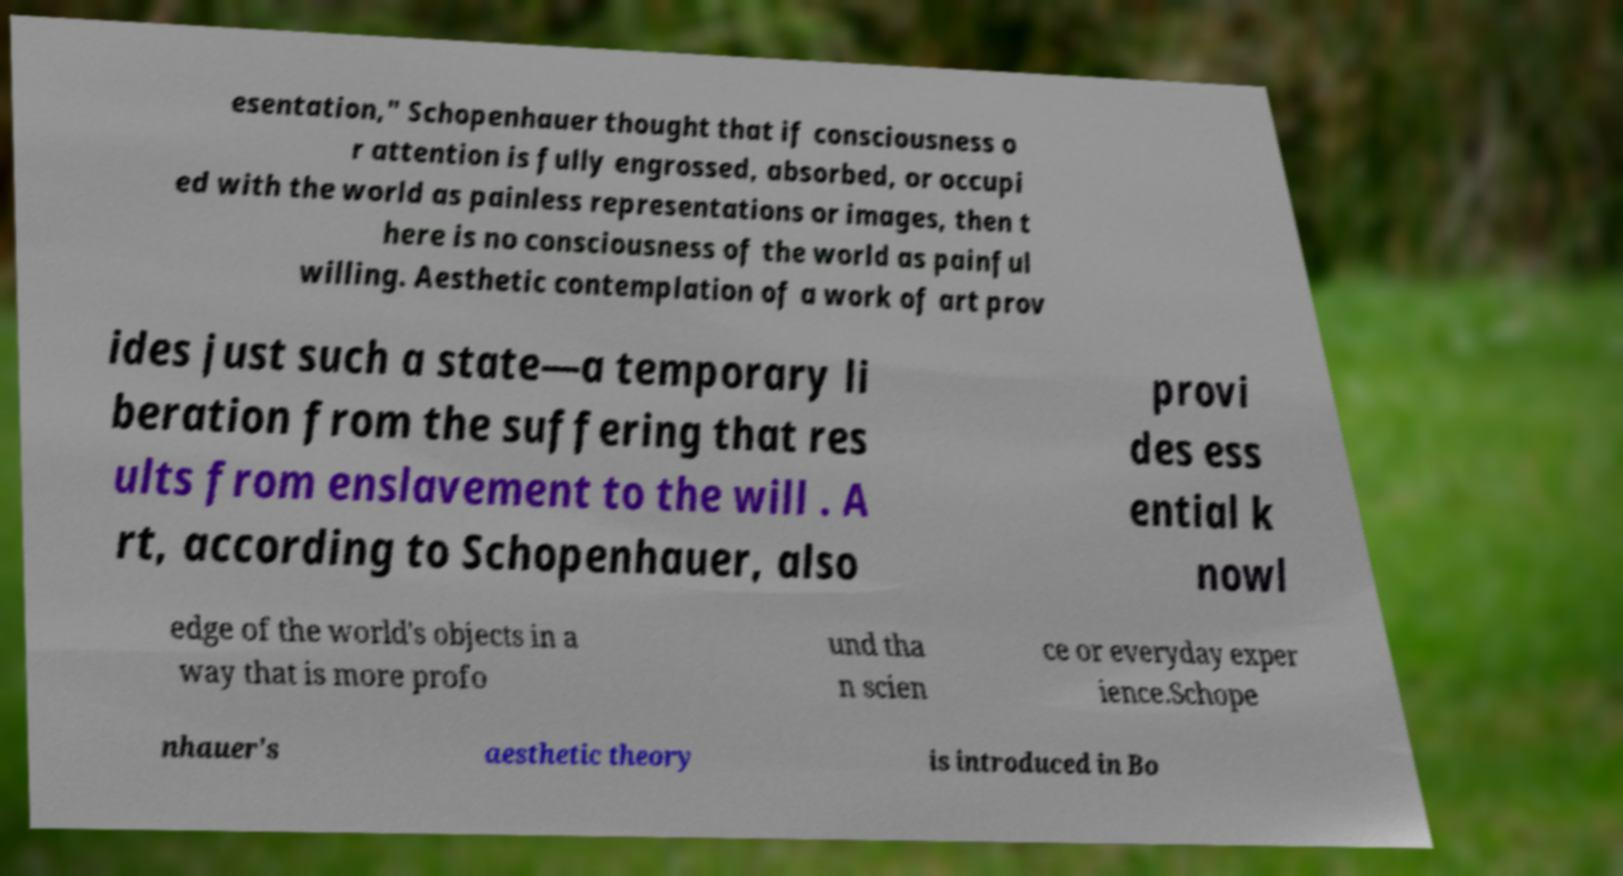Please read and relay the text visible in this image. What does it say? esentation," Schopenhauer thought that if consciousness o r attention is fully engrossed, absorbed, or occupi ed with the world as painless representations or images, then t here is no consciousness of the world as painful willing. Aesthetic contemplation of a work of art prov ides just such a state—a temporary li beration from the suffering that res ults from enslavement to the will . A rt, according to Schopenhauer, also provi des ess ential k nowl edge of the world's objects in a way that is more profo und tha n scien ce or everyday exper ience.Schope nhauer's aesthetic theory is introduced in Bo 